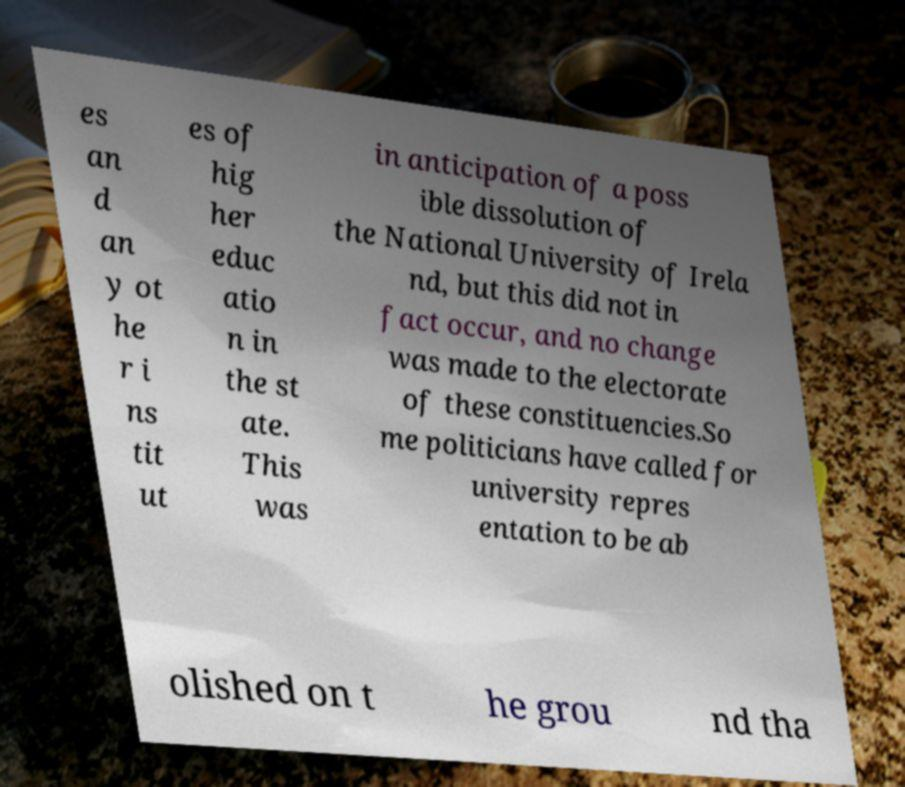Could you extract and type out the text from this image? es an d an y ot he r i ns tit ut es of hig her educ atio n in the st ate. This was in anticipation of a poss ible dissolution of the National University of Irela nd, but this did not in fact occur, and no change was made to the electorate of these constituencies.So me politicians have called for university repres entation to be ab olished on t he grou nd tha 